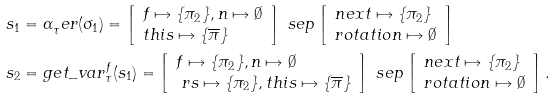<formula> <loc_0><loc_0><loc_500><loc_500>s _ { 1 } & = \alpha _ { \tau } ^ { \ } e r ( \sigma _ { 1 } ) = \left [ \begin{array} { l } f \mapsto \{ \pi _ { 2 } \} , n \mapsto \emptyset \\ t h i s \mapsto \{ \overline { \pi } \} \end{array} \right ] \ s e p \left [ \begin{array} { l } n e x t \mapsto \{ \pi _ { 2 } \} \\ r o t a t i o n \mapsto \emptyset \end{array} \right ] \\ s _ { 2 } & = g e t \_ v a r _ { \tau } ^ { f } ( s _ { 1 } ) = \left [ \begin{array} { l } f \mapsto \{ \pi _ { 2 } \} , n \mapsto \emptyset \\ \ r s \mapsto \{ \pi _ { 2 } \} , t h i s \mapsto \{ \overline { \pi } \} \end{array} \right ] \ s e p \left [ \begin{array} { l } n e x t \mapsto \{ \pi _ { 2 } \} \\ r o t a t i o n \mapsto \emptyset \end{array} \right ] .</formula> 